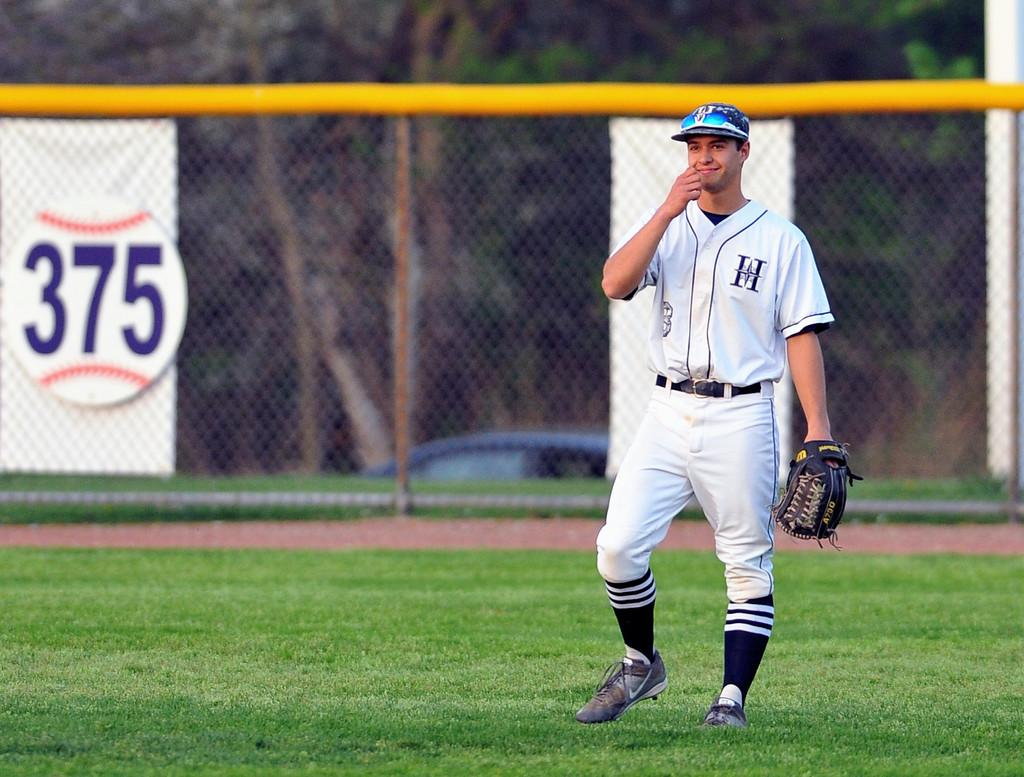<image>
Share a concise interpretation of the image provided. a person in a jersey with the letter H 